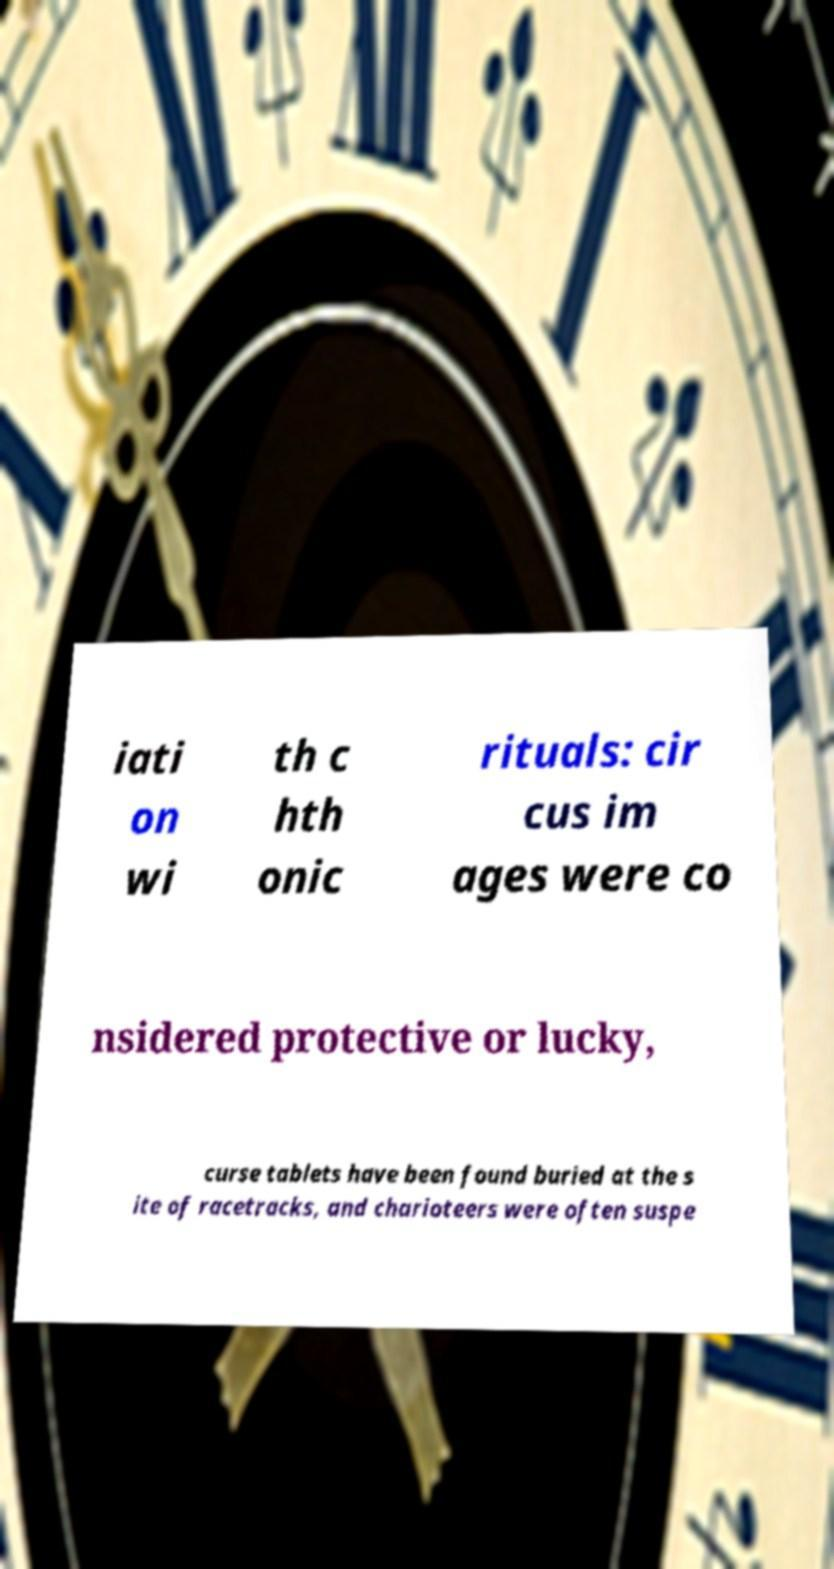There's text embedded in this image that I need extracted. Can you transcribe it verbatim? iati on wi th c hth onic rituals: cir cus im ages were co nsidered protective or lucky, curse tablets have been found buried at the s ite of racetracks, and charioteers were often suspe 